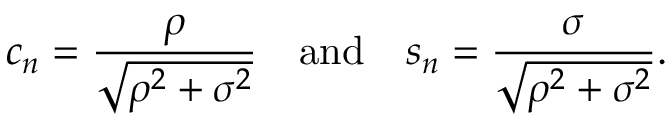<formula> <loc_0><loc_0><loc_500><loc_500>c _ { n } = { \frac { \rho } { \sqrt { \rho ^ { 2 } + \sigma ^ { 2 } } } } \quad a n d \quad s _ { n } = { \frac { \sigma } { \sqrt { \rho ^ { 2 } + \sigma ^ { 2 } } } } .</formula> 